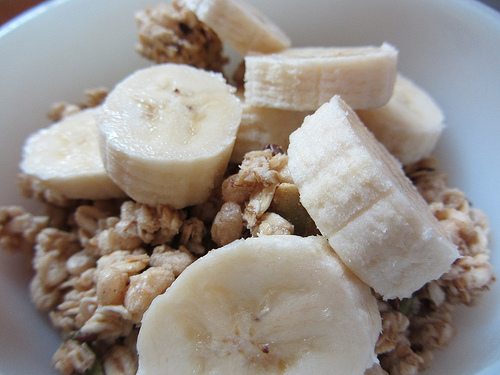<image>
Is there a cereal in the banana? No. The cereal is not contained within the banana. These objects have a different spatial relationship. Is there a banana on the channa? Yes. Looking at the image, I can see the banana is positioned on top of the channa, with the channa providing support. 